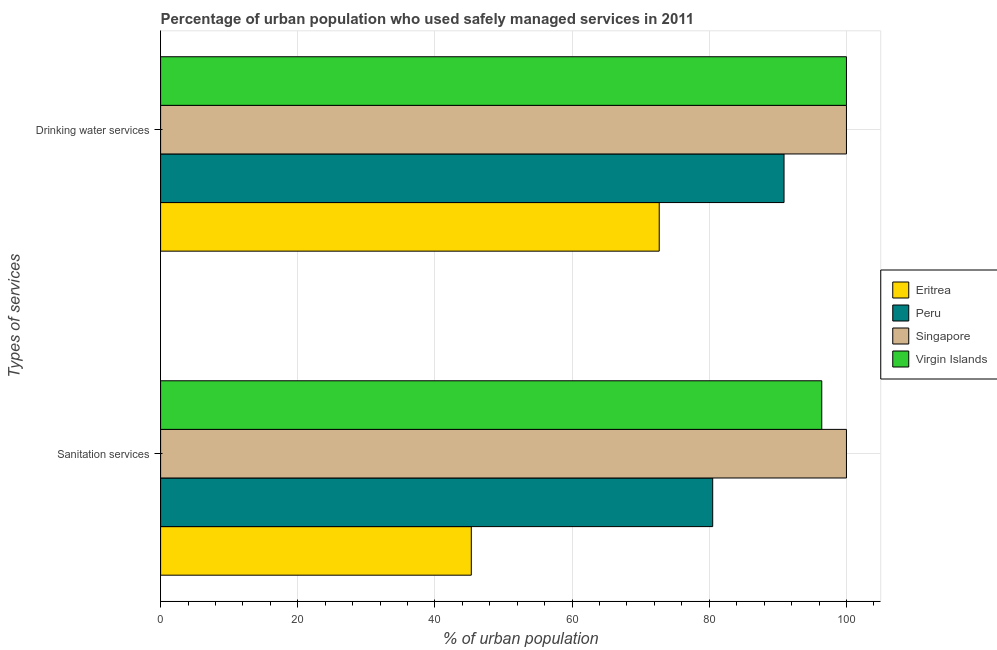How many groups of bars are there?
Keep it short and to the point. 2. Are the number of bars on each tick of the Y-axis equal?
Provide a short and direct response. Yes. How many bars are there on the 1st tick from the bottom?
Provide a succinct answer. 4. What is the label of the 2nd group of bars from the top?
Provide a succinct answer. Sanitation services. What is the percentage of urban population who used sanitation services in Peru?
Your response must be concise. 80.5. Across all countries, what is the minimum percentage of urban population who used drinking water services?
Your answer should be compact. 72.7. In which country was the percentage of urban population who used drinking water services maximum?
Your answer should be very brief. Singapore. In which country was the percentage of urban population who used sanitation services minimum?
Provide a succinct answer. Eritrea. What is the total percentage of urban population who used sanitation services in the graph?
Your response must be concise. 322.2. What is the difference between the percentage of urban population who used sanitation services in Virgin Islands and that in Singapore?
Your answer should be very brief. -3.6. What is the difference between the percentage of urban population who used sanitation services in Peru and the percentage of urban population who used drinking water services in Eritrea?
Ensure brevity in your answer.  7.8. What is the average percentage of urban population who used sanitation services per country?
Provide a short and direct response. 80.55. What is the difference between the percentage of urban population who used sanitation services and percentage of urban population who used drinking water services in Eritrea?
Your answer should be compact. -27.4. What is the ratio of the percentage of urban population who used sanitation services in Eritrea to that in Virgin Islands?
Offer a terse response. 0.47. What does the 2nd bar from the top in Sanitation services represents?
Provide a short and direct response. Singapore. What does the 4th bar from the bottom in Sanitation services represents?
Offer a very short reply. Virgin Islands. Are the values on the major ticks of X-axis written in scientific E-notation?
Your answer should be very brief. No. Does the graph contain grids?
Give a very brief answer. Yes. Where does the legend appear in the graph?
Keep it short and to the point. Center right. How are the legend labels stacked?
Ensure brevity in your answer.  Vertical. What is the title of the graph?
Offer a very short reply. Percentage of urban population who used safely managed services in 2011. What is the label or title of the X-axis?
Your response must be concise. % of urban population. What is the label or title of the Y-axis?
Offer a terse response. Types of services. What is the % of urban population in Eritrea in Sanitation services?
Provide a succinct answer. 45.3. What is the % of urban population in Peru in Sanitation services?
Provide a succinct answer. 80.5. What is the % of urban population in Virgin Islands in Sanitation services?
Your answer should be very brief. 96.4. What is the % of urban population in Eritrea in Drinking water services?
Your answer should be very brief. 72.7. What is the % of urban population of Peru in Drinking water services?
Your answer should be very brief. 90.9. What is the % of urban population in Singapore in Drinking water services?
Your response must be concise. 100. What is the % of urban population of Virgin Islands in Drinking water services?
Make the answer very short. 100. Across all Types of services, what is the maximum % of urban population in Eritrea?
Your answer should be very brief. 72.7. Across all Types of services, what is the maximum % of urban population in Peru?
Provide a succinct answer. 90.9. Across all Types of services, what is the maximum % of urban population in Singapore?
Give a very brief answer. 100. Across all Types of services, what is the maximum % of urban population of Virgin Islands?
Give a very brief answer. 100. Across all Types of services, what is the minimum % of urban population of Eritrea?
Make the answer very short. 45.3. Across all Types of services, what is the minimum % of urban population in Peru?
Your answer should be compact. 80.5. Across all Types of services, what is the minimum % of urban population of Singapore?
Ensure brevity in your answer.  100. Across all Types of services, what is the minimum % of urban population of Virgin Islands?
Your answer should be compact. 96.4. What is the total % of urban population in Eritrea in the graph?
Your response must be concise. 118. What is the total % of urban population of Peru in the graph?
Provide a short and direct response. 171.4. What is the total % of urban population in Singapore in the graph?
Your answer should be compact. 200. What is the total % of urban population of Virgin Islands in the graph?
Keep it short and to the point. 196.4. What is the difference between the % of urban population in Eritrea in Sanitation services and that in Drinking water services?
Offer a very short reply. -27.4. What is the difference between the % of urban population of Peru in Sanitation services and that in Drinking water services?
Your answer should be compact. -10.4. What is the difference between the % of urban population of Virgin Islands in Sanitation services and that in Drinking water services?
Keep it short and to the point. -3.6. What is the difference between the % of urban population in Eritrea in Sanitation services and the % of urban population in Peru in Drinking water services?
Make the answer very short. -45.6. What is the difference between the % of urban population of Eritrea in Sanitation services and the % of urban population of Singapore in Drinking water services?
Offer a very short reply. -54.7. What is the difference between the % of urban population in Eritrea in Sanitation services and the % of urban population in Virgin Islands in Drinking water services?
Provide a short and direct response. -54.7. What is the difference between the % of urban population of Peru in Sanitation services and the % of urban population of Singapore in Drinking water services?
Keep it short and to the point. -19.5. What is the difference between the % of urban population in Peru in Sanitation services and the % of urban population in Virgin Islands in Drinking water services?
Keep it short and to the point. -19.5. What is the average % of urban population of Peru per Types of services?
Give a very brief answer. 85.7. What is the average % of urban population in Singapore per Types of services?
Offer a terse response. 100. What is the average % of urban population in Virgin Islands per Types of services?
Keep it short and to the point. 98.2. What is the difference between the % of urban population of Eritrea and % of urban population of Peru in Sanitation services?
Offer a very short reply. -35.2. What is the difference between the % of urban population in Eritrea and % of urban population in Singapore in Sanitation services?
Offer a very short reply. -54.7. What is the difference between the % of urban population in Eritrea and % of urban population in Virgin Islands in Sanitation services?
Offer a very short reply. -51.1. What is the difference between the % of urban population of Peru and % of urban population of Singapore in Sanitation services?
Offer a very short reply. -19.5. What is the difference between the % of urban population of Peru and % of urban population of Virgin Islands in Sanitation services?
Offer a very short reply. -15.9. What is the difference between the % of urban population in Singapore and % of urban population in Virgin Islands in Sanitation services?
Ensure brevity in your answer.  3.6. What is the difference between the % of urban population in Eritrea and % of urban population in Peru in Drinking water services?
Your answer should be very brief. -18.2. What is the difference between the % of urban population in Eritrea and % of urban population in Singapore in Drinking water services?
Offer a very short reply. -27.3. What is the difference between the % of urban population in Eritrea and % of urban population in Virgin Islands in Drinking water services?
Make the answer very short. -27.3. What is the ratio of the % of urban population of Eritrea in Sanitation services to that in Drinking water services?
Provide a short and direct response. 0.62. What is the ratio of the % of urban population in Peru in Sanitation services to that in Drinking water services?
Your answer should be very brief. 0.89. What is the ratio of the % of urban population of Singapore in Sanitation services to that in Drinking water services?
Ensure brevity in your answer.  1. What is the difference between the highest and the second highest % of urban population of Eritrea?
Make the answer very short. 27.4. What is the difference between the highest and the second highest % of urban population in Virgin Islands?
Your answer should be compact. 3.6. What is the difference between the highest and the lowest % of urban population of Eritrea?
Ensure brevity in your answer.  27.4. What is the difference between the highest and the lowest % of urban population in Singapore?
Offer a very short reply. 0. 